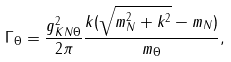<formula> <loc_0><loc_0><loc_500><loc_500>\Gamma _ { \Theta } = \frac { g _ { K N \Theta } ^ { 2 } } { 2 \pi } \frac { k ( \sqrt { m _ { N } ^ { 2 } + k ^ { 2 } } - m _ { N } ) } { m _ { \Theta } } ,</formula> 